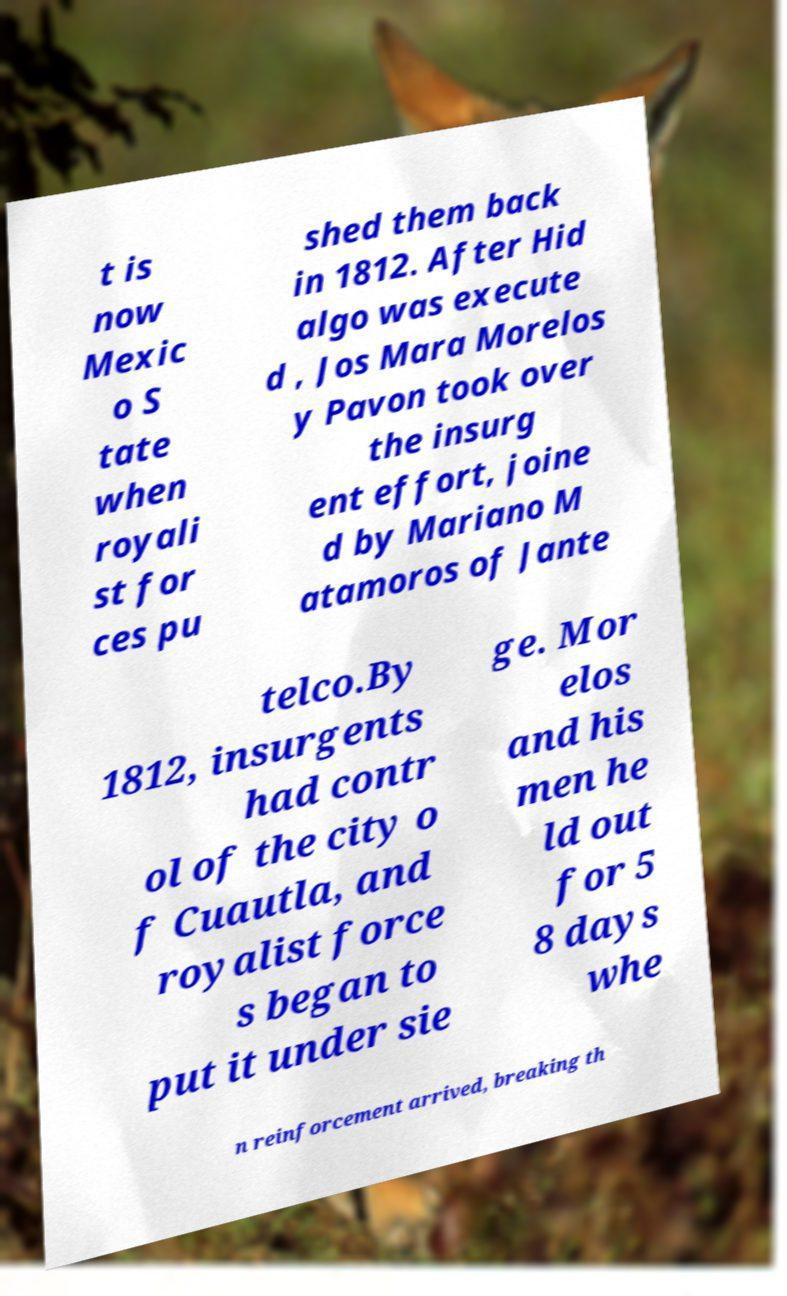Can you accurately transcribe the text from the provided image for me? t is now Mexic o S tate when royali st for ces pu shed them back in 1812. After Hid algo was execute d , Jos Mara Morelos y Pavon took over the insurg ent effort, joine d by Mariano M atamoros of Jante telco.By 1812, insurgents had contr ol of the city o f Cuautla, and royalist force s began to put it under sie ge. Mor elos and his men he ld out for 5 8 days whe n reinforcement arrived, breaking th 